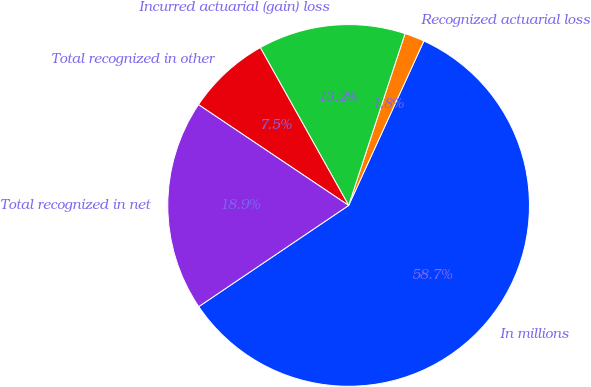Convert chart to OTSL. <chart><loc_0><loc_0><loc_500><loc_500><pie_chart><fcel>In millions<fcel>Recognized actuarial loss<fcel>Incurred actuarial (gain) loss<fcel>Total recognized in other<fcel>Total recognized in net<nl><fcel>58.72%<fcel>1.78%<fcel>13.17%<fcel>7.47%<fcel>18.86%<nl></chart> 